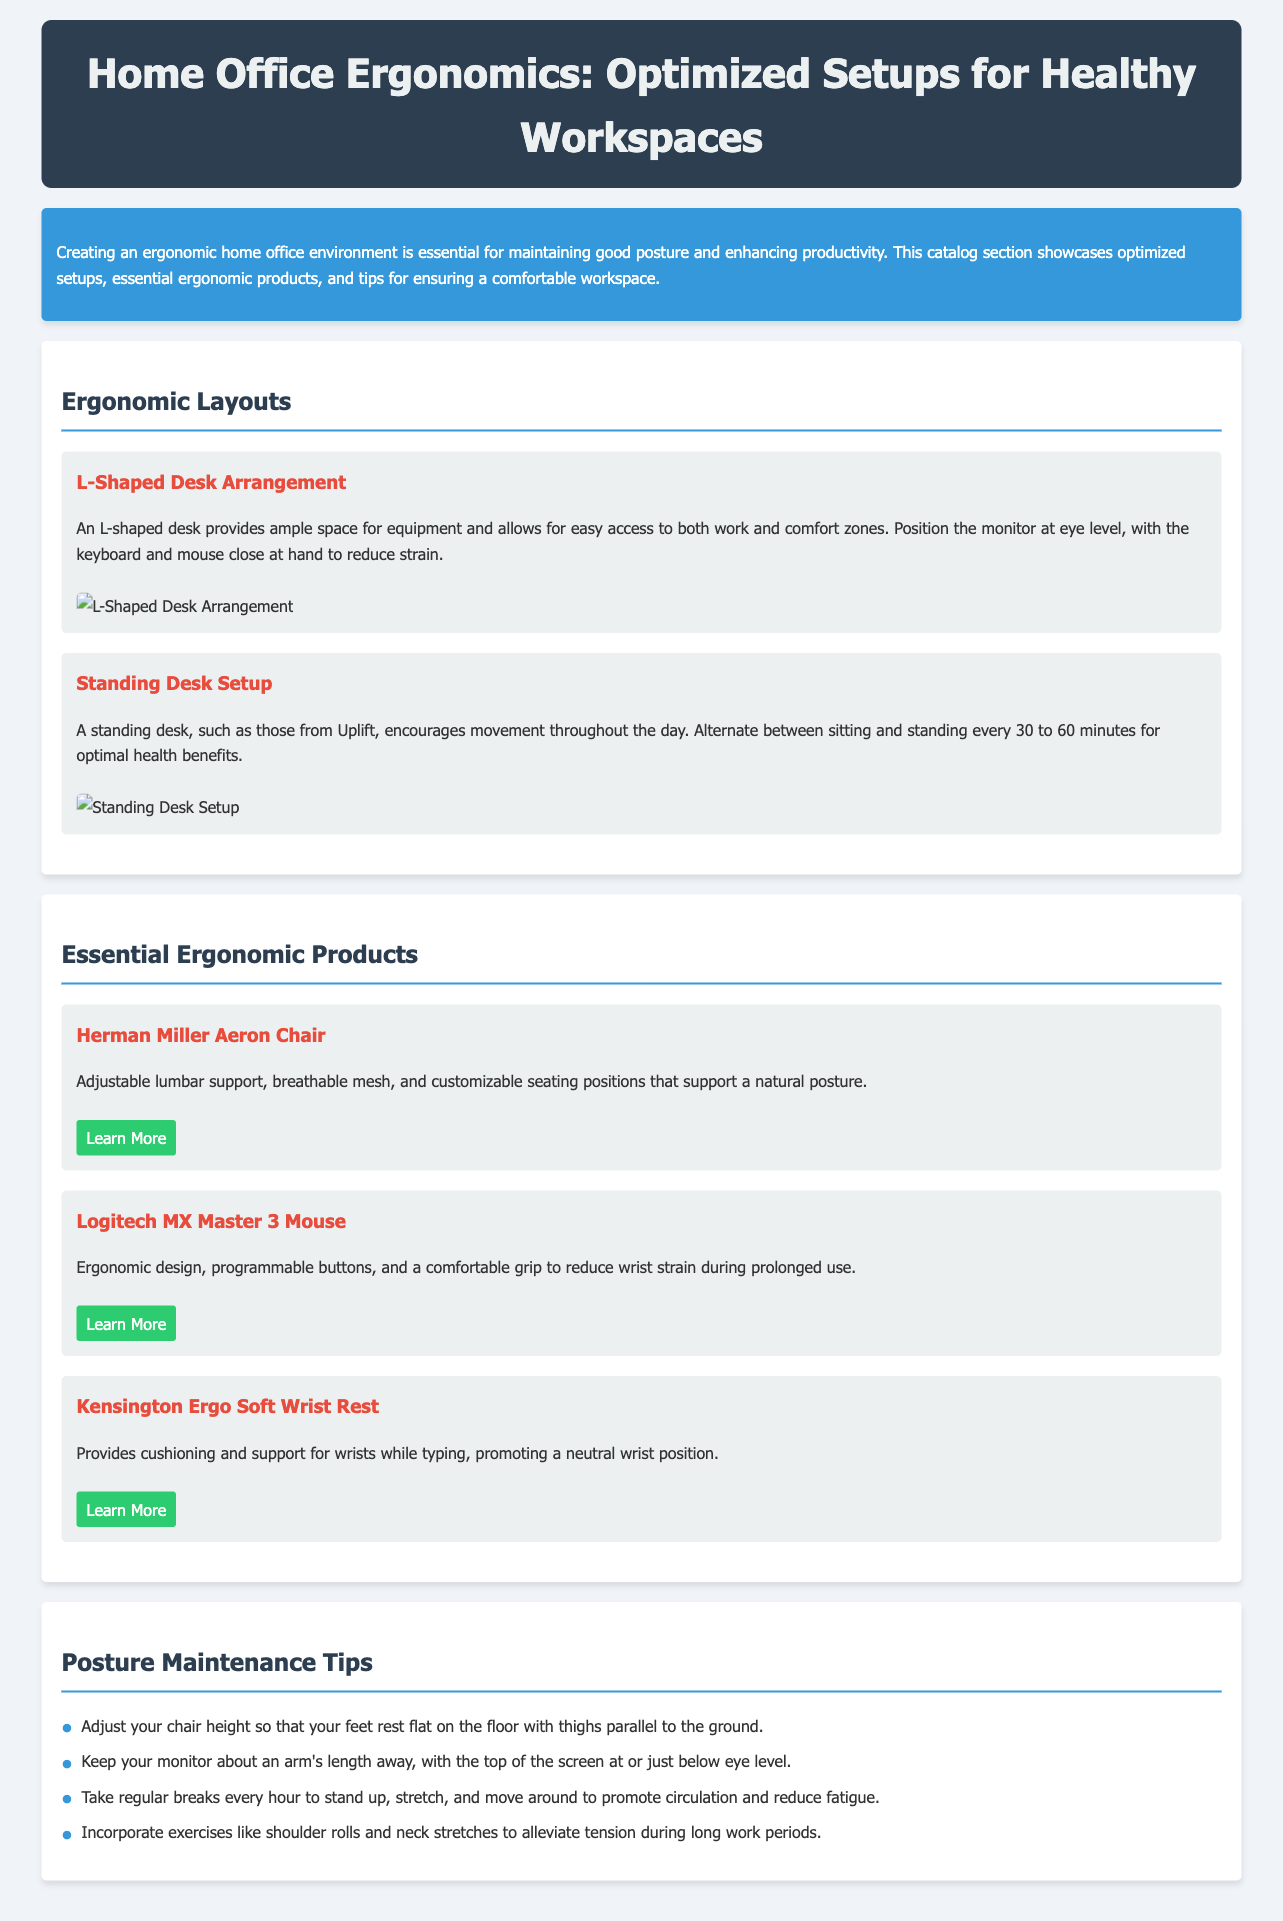What is the title of the catalog? The title of the catalog is the main heading presented in the header section.
Answer: Home Office Ergonomics: Optimized Setups for Healthy Workspaces What does the introduction section emphasize? The introduction section highlights the importance of creating an ergonomic home office for posture and productivity.
Answer: Maintaining good posture and enhancing productivity What is one type of ergonomic layout mentioned? The document lists layouts that are designed to optimize workspace efficiency and comfort, one of which is specified.
Answer: L-Shaped Desk Arrangement What is the recommended frequency for alternating between sitting and standing? The standing desk setup suggests a specific interval for changing positions to promote health.
Answer: Every 30 to 60 minutes Which ergonomic product offers adjustable lumbar support? The document lists products and one of them specifically includes features supporting posture.
Answer: Herman Miller Aeron Chair What essential ergonomic product is recommended for wrist support? The catalog mentions a product specifically designed to provide cushioning and support for wrists.
Answer: Kensington Ergo Soft Wrist Rest What is one posture maintenance tip provided? The document lists several tips, and one of them addresses chair height adjustment.
Answer: Adjust your chair height What is the color of the header background? The specific aesthetic elements of the document are characterized by color choices made in the design.
Answer: Dark blue Which company makes the MX Master 3 Mouse? The document references a specific product along with its manufacturer, which reveals this information directly.
Answer: Logitech 